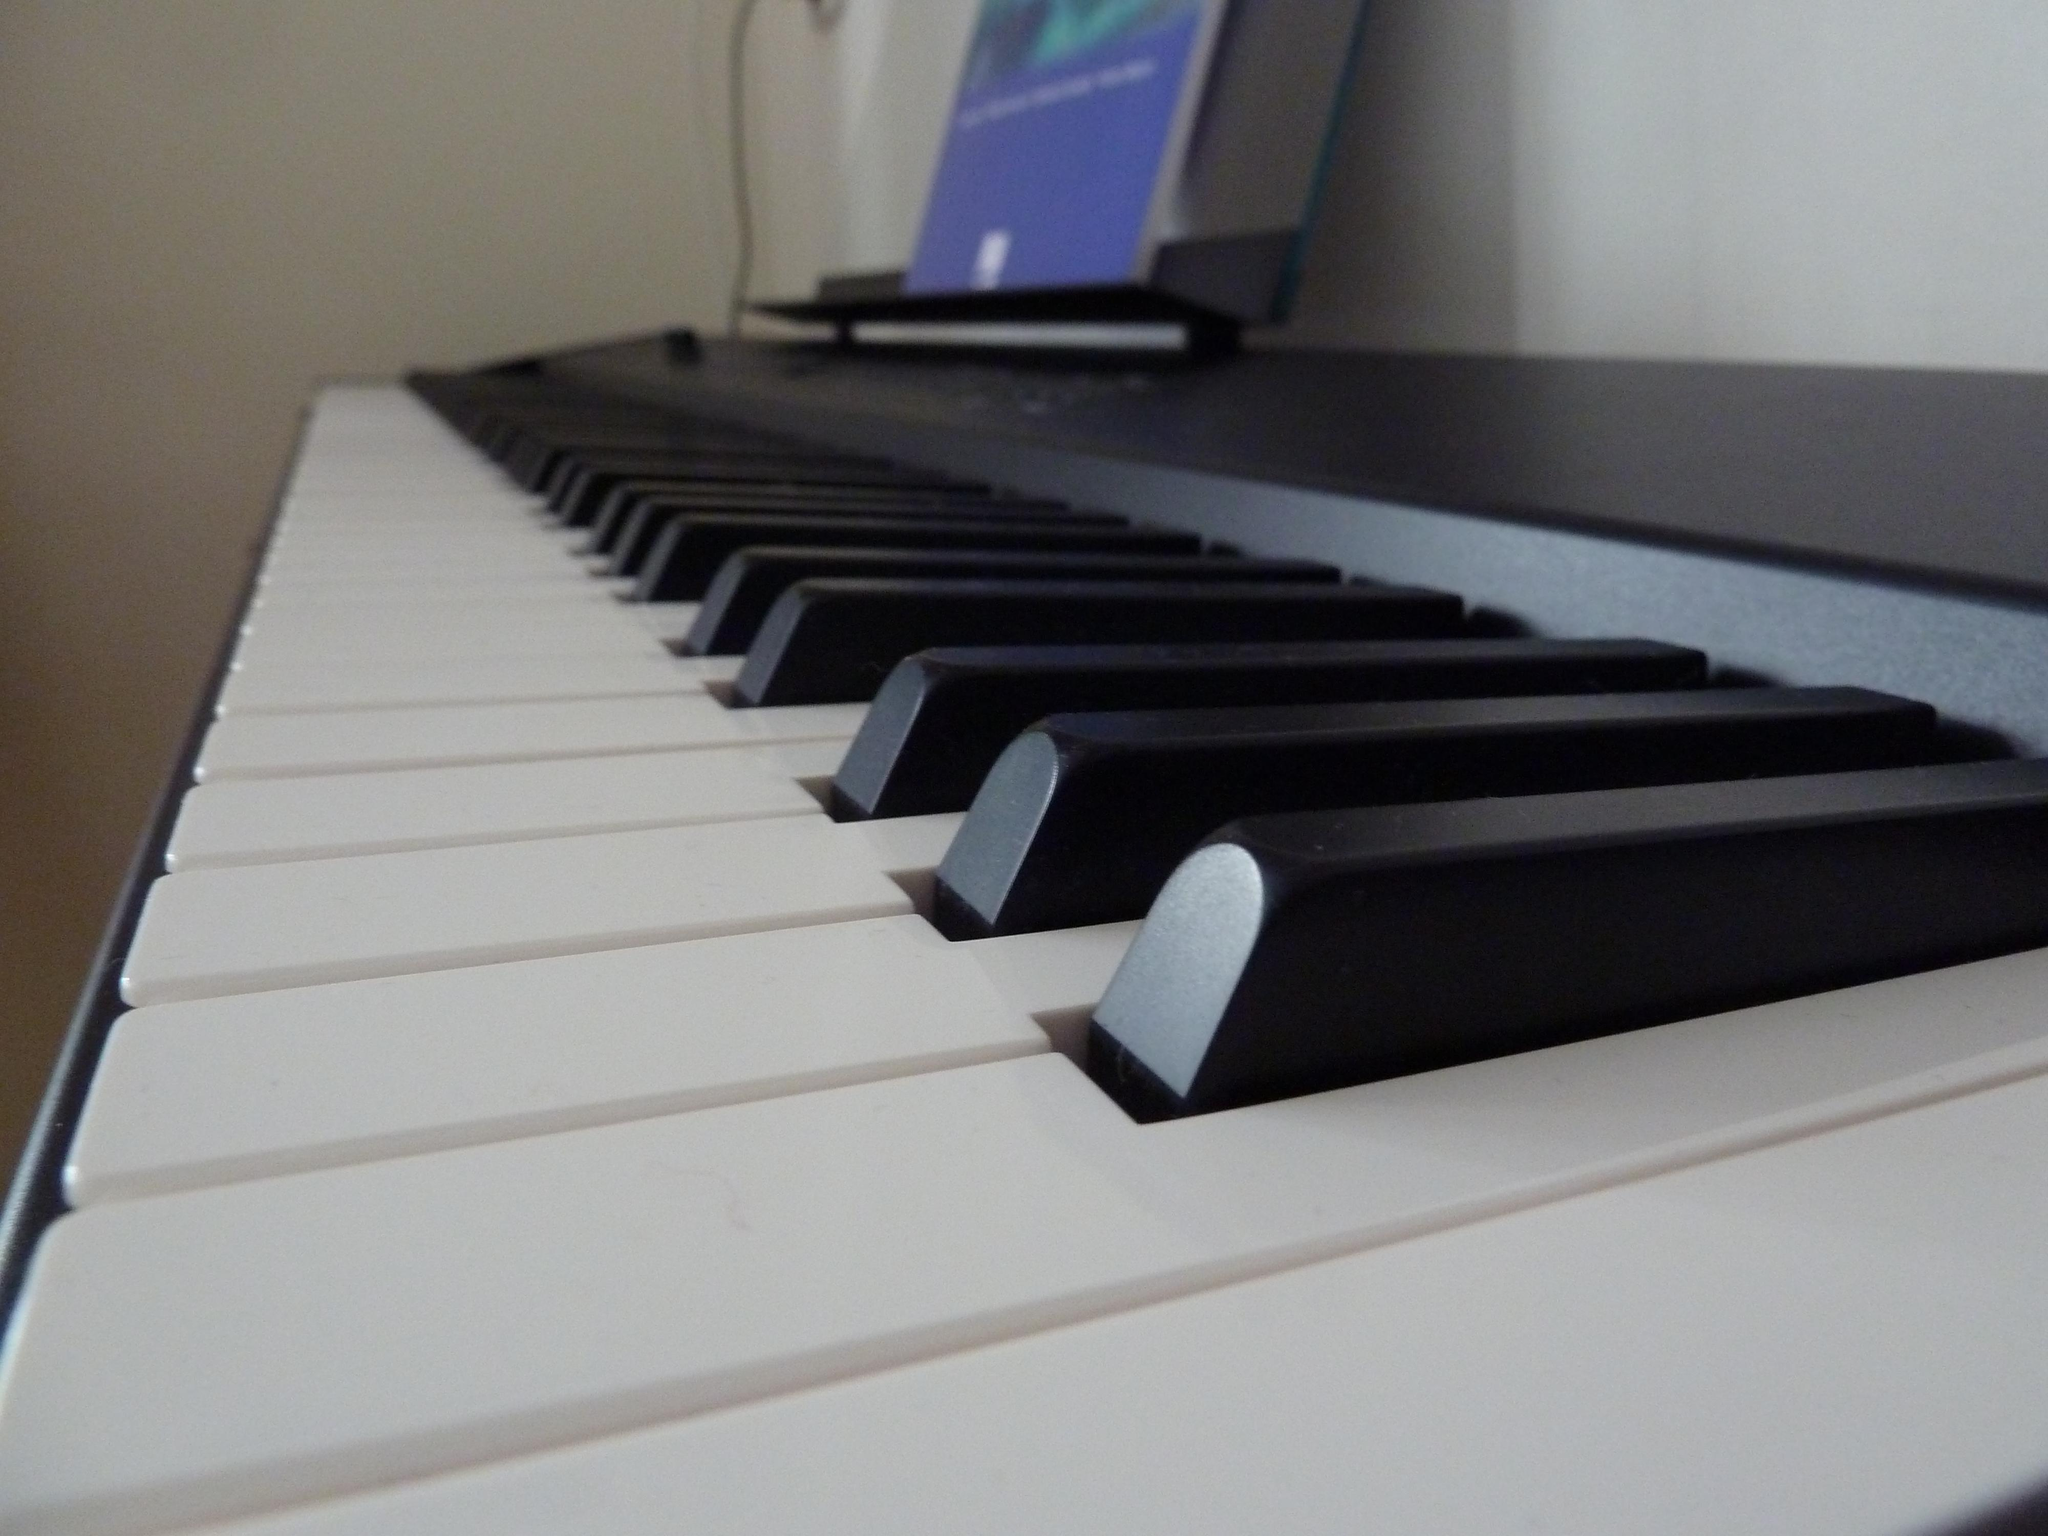What type of wall can be seen in the background of the image? There is a wall with white paint in the background. What musical instrument is present in the image? There is a piano in the image. What color is the piano? The piano is black and white in color. How many stitches are required to create the sail on the piano in the image? There is no sail present on the piano in the image, as it is a musical instrument and not a sailboat. 